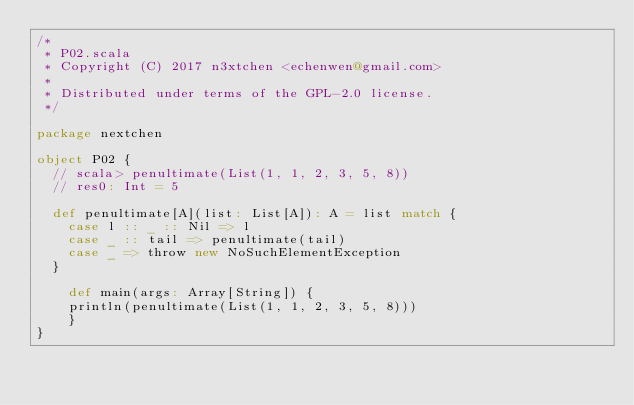Convert code to text. <code><loc_0><loc_0><loc_500><loc_500><_Scala_>/*
 * P02.scala
 * Copyright (C) 2017 n3xtchen <echenwen@gmail.com>
 *
 * Distributed under terms of the GPL-2.0 license.
 */

package nextchen

object P02 {
  // scala> penultimate(List(1, 1, 2, 3, 5, 8))
  // res0: Int = 5

  def penultimate[A](list: List[A]): A = list match {
    case l :: _ :: Nil => l
    case _ :: tail => penultimate(tail)
    case _ => throw new NoSuchElementException
  }

	def main(args: Array[String]) {
    println(penultimate(List(1, 1, 2, 3, 5, 8)))
	}
}

</code> 